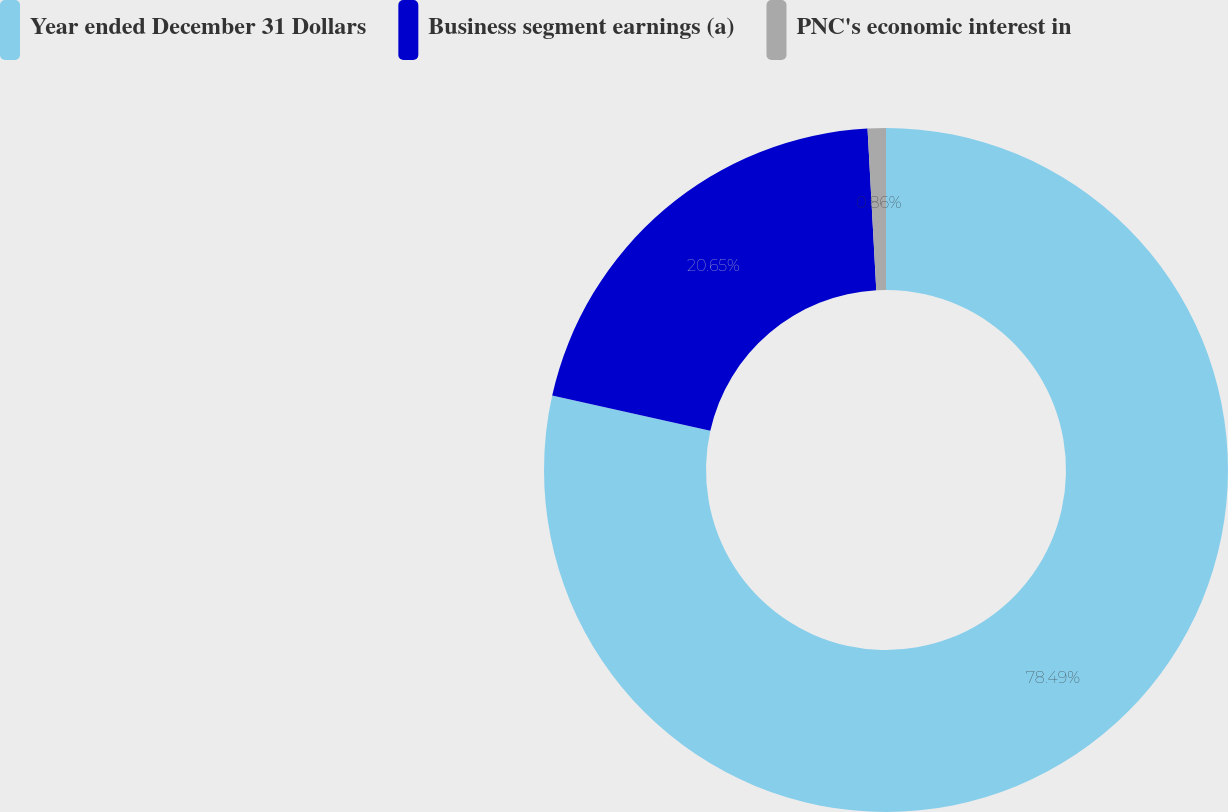<chart> <loc_0><loc_0><loc_500><loc_500><pie_chart><fcel>Year ended December 31 Dollars<fcel>Business segment earnings (a)<fcel>PNC's economic interest in<nl><fcel>78.49%<fcel>20.65%<fcel>0.86%<nl></chart> 